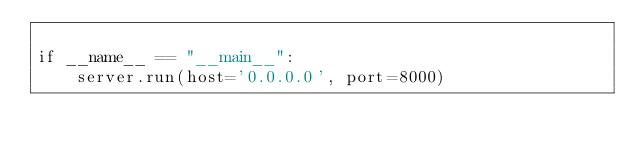Convert code to text. <code><loc_0><loc_0><loc_500><loc_500><_Python_>
if __name__ == "__main__":
    server.run(host='0.0.0.0', port=8000)

</code> 